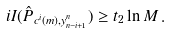Convert formula to latex. <formula><loc_0><loc_0><loc_500><loc_500>i I ( \hat { P } _ { c ^ { i } ( m ) , y _ { n - i + 1 } ^ { n } } ) \geq t _ { 2 } \ln M \, .</formula> 